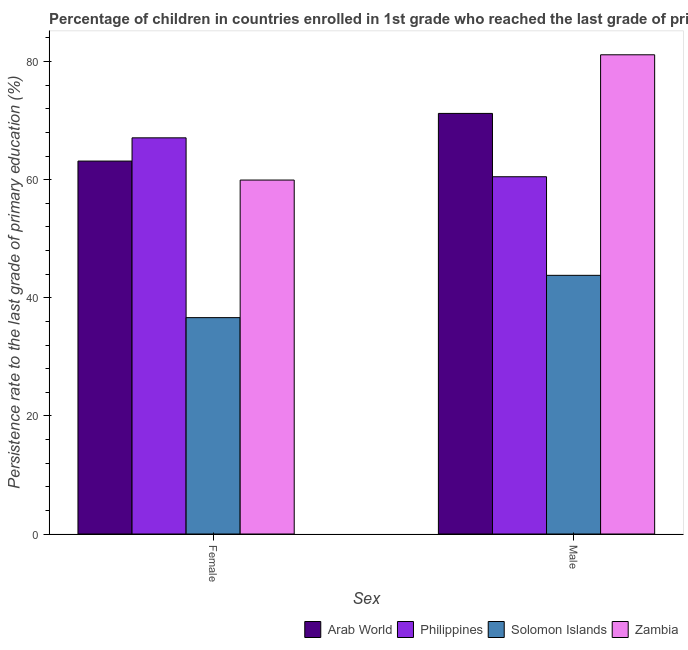How many groups of bars are there?
Offer a very short reply. 2. Are the number of bars per tick equal to the number of legend labels?
Your answer should be very brief. Yes. How many bars are there on the 1st tick from the right?
Your response must be concise. 4. What is the persistence rate of male students in Solomon Islands?
Provide a succinct answer. 43.81. Across all countries, what is the maximum persistence rate of female students?
Give a very brief answer. 67.09. Across all countries, what is the minimum persistence rate of male students?
Keep it short and to the point. 43.81. In which country was the persistence rate of male students maximum?
Keep it short and to the point. Zambia. In which country was the persistence rate of female students minimum?
Ensure brevity in your answer.  Solomon Islands. What is the total persistence rate of female students in the graph?
Offer a very short reply. 226.83. What is the difference between the persistence rate of male students in Philippines and that in Arab World?
Give a very brief answer. -10.73. What is the difference between the persistence rate of female students in Philippines and the persistence rate of male students in Arab World?
Your answer should be very brief. -4.14. What is the average persistence rate of male students per country?
Provide a short and direct response. 64.17. What is the difference between the persistence rate of male students and persistence rate of female students in Zambia?
Your answer should be compact. 21.22. What is the ratio of the persistence rate of male students in Philippines to that in Arab World?
Offer a terse response. 0.85. Is the persistence rate of male students in Zambia less than that in Solomon Islands?
Offer a terse response. No. What does the 4th bar from the left in Female represents?
Make the answer very short. Zambia. What does the 1st bar from the right in Male represents?
Give a very brief answer. Zambia. How many bars are there?
Provide a succinct answer. 8. Are all the bars in the graph horizontal?
Your answer should be very brief. No. How many countries are there in the graph?
Provide a short and direct response. 4. What is the difference between two consecutive major ticks on the Y-axis?
Offer a very short reply. 20. Where does the legend appear in the graph?
Provide a succinct answer. Bottom right. How many legend labels are there?
Offer a terse response. 4. How are the legend labels stacked?
Make the answer very short. Horizontal. What is the title of the graph?
Give a very brief answer. Percentage of children in countries enrolled in 1st grade who reached the last grade of primary education. Does "Dominica" appear as one of the legend labels in the graph?
Your answer should be compact. No. What is the label or title of the X-axis?
Your answer should be very brief. Sex. What is the label or title of the Y-axis?
Offer a terse response. Persistence rate to the last grade of primary education (%). What is the Persistence rate to the last grade of primary education (%) of Arab World in Female?
Provide a short and direct response. 63.16. What is the Persistence rate to the last grade of primary education (%) of Philippines in Female?
Your answer should be very brief. 67.09. What is the Persistence rate to the last grade of primary education (%) of Solomon Islands in Female?
Offer a terse response. 36.64. What is the Persistence rate to the last grade of primary education (%) of Zambia in Female?
Give a very brief answer. 59.94. What is the Persistence rate to the last grade of primary education (%) of Arab World in Male?
Offer a very short reply. 71.23. What is the Persistence rate to the last grade of primary education (%) in Philippines in Male?
Offer a terse response. 60.5. What is the Persistence rate to the last grade of primary education (%) of Solomon Islands in Male?
Ensure brevity in your answer.  43.81. What is the Persistence rate to the last grade of primary education (%) in Zambia in Male?
Your response must be concise. 81.16. Across all Sex, what is the maximum Persistence rate to the last grade of primary education (%) of Arab World?
Keep it short and to the point. 71.23. Across all Sex, what is the maximum Persistence rate to the last grade of primary education (%) in Philippines?
Offer a very short reply. 67.09. Across all Sex, what is the maximum Persistence rate to the last grade of primary education (%) in Solomon Islands?
Offer a very short reply. 43.81. Across all Sex, what is the maximum Persistence rate to the last grade of primary education (%) in Zambia?
Your response must be concise. 81.16. Across all Sex, what is the minimum Persistence rate to the last grade of primary education (%) of Arab World?
Your answer should be compact. 63.16. Across all Sex, what is the minimum Persistence rate to the last grade of primary education (%) of Philippines?
Keep it short and to the point. 60.5. Across all Sex, what is the minimum Persistence rate to the last grade of primary education (%) in Solomon Islands?
Make the answer very short. 36.64. Across all Sex, what is the minimum Persistence rate to the last grade of primary education (%) in Zambia?
Provide a succinct answer. 59.94. What is the total Persistence rate to the last grade of primary education (%) of Arab World in the graph?
Give a very brief answer. 134.39. What is the total Persistence rate to the last grade of primary education (%) in Philippines in the graph?
Provide a short and direct response. 127.59. What is the total Persistence rate to the last grade of primary education (%) of Solomon Islands in the graph?
Give a very brief answer. 80.45. What is the total Persistence rate to the last grade of primary education (%) of Zambia in the graph?
Offer a very short reply. 141.1. What is the difference between the Persistence rate to the last grade of primary education (%) of Arab World in Female and that in Male?
Provide a short and direct response. -8.07. What is the difference between the Persistence rate to the last grade of primary education (%) in Philippines in Female and that in Male?
Provide a succinct answer. 6.59. What is the difference between the Persistence rate to the last grade of primary education (%) of Solomon Islands in Female and that in Male?
Offer a terse response. -7.16. What is the difference between the Persistence rate to the last grade of primary education (%) in Zambia in Female and that in Male?
Provide a succinct answer. -21.22. What is the difference between the Persistence rate to the last grade of primary education (%) in Arab World in Female and the Persistence rate to the last grade of primary education (%) in Philippines in Male?
Make the answer very short. 2.65. What is the difference between the Persistence rate to the last grade of primary education (%) in Arab World in Female and the Persistence rate to the last grade of primary education (%) in Solomon Islands in Male?
Offer a terse response. 19.35. What is the difference between the Persistence rate to the last grade of primary education (%) in Arab World in Female and the Persistence rate to the last grade of primary education (%) in Zambia in Male?
Make the answer very short. -18. What is the difference between the Persistence rate to the last grade of primary education (%) of Philippines in Female and the Persistence rate to the last grade of primary education (%) of Solomon Islands in Male?
Make the answer very short. 23.29. What is the difference between the Persistence rate to the last grade of primary education (%) in Philippines in Female and the Persistence rate to the last grade of primary education (%) in Zambia in Male?
Offer a very short reply. -14.06. What is the difference between the Persistence rate to the last grade of primary education (%) in Solomon Islands in Female and the Persistence rate to the last grade of primary education (%) in Zambia in Male?
Give a very brief answer. -44.51. What is the average Persistence rate to the last grade of primary education (%) in Arab World per Sex?
Your response must be concise. 67.19. What is the average Persistence rate to the last grade of primary education (%) in Philippines per Sex?
Your answer should be compact. 63.8. What is the average Persistence rate to the last grade of primary education (%) of Solomon Islands per Sex?
Your answer should be compact. 40.22. What is the average Persistence rate to the last grade of primary education (%) of Zambia per Sex?
Give a very brief answer. 70.55. What is the difference between the Persistence rate to the last grade of primary education (%) of Arab World and Persistence rate to the last grade of primary education (%) of Philippines in Female?
Offer a very short reply. -3.93. What is the difference between the Persistence rate to the last grade of primary education (%) in Arab World and Persistence rate to the last grade of primary education (%) in Solomon Islands in Female?
Give a very brief answer. 26.52. What is the difference between the Persistence rate to the last grade of primary education (%) in Arab World and Persistence rate to the last grade of primary education (%) in Zambia in Female?
Provide a succinct answer. 3.22. What is the difference between the Persistence rate to the last grade of primary education (%) in Philippines and Persistence rate to the last grade of primary education (%) in Solomon Islands in Female?
Provide a succinct answer. 30.45. What is the difference between the Persistence rate to the last grade of primary education (%) of Philippines and Persistence rate to the last grade of primary education (%) of Zambia in Female?
Your response must be concise. 7.15. What is the difference between the Persistence rate to the last grade of primary education (%) of Solomon Islands and Persistence rate to the last grade of primary education (%) of Zambia in Female?
Keep it short and to the point. -23.3. What is the difference between the Persistence rate to the last grade of primary education (%) in Arab World and Persistence rate to the last grade of primary education (%) in Philippines in Male?
Provide a short and direct response. 10.73. What is the difference between the Persistence rate to the last grade of primary education (%) in Arab World and Persistence rate to the last grade of primary education (%) in Solomon Islands in Male?
Provide a succinct answer. 27.42. What is the difference between the Persistence rate to the last grade of primary education (%) of Arab World and Persistence rate to the last grade of primary education (%) of Zambia in Male?
Ensure brevity in your answer.  -9.93. What is the difference between the Persistence rate to the last grade of primary education (%) of Philippines and Persistence rate to the last grade of primary education (%) of Solomon Islands in Male?
Provide a short and direct response. 16.7. What is the difference between the Persistence rate to the last grade of primary education (%) in Philippines and Persistence rate to the last grade of primary education (%) in Zambia in Male?
Give a very brief answer. -20.65. What is the difference between the Persistence rate to the last grade of primary education (%) of Solomon Islands and Persistence rate to the last grade of primary education (%) of Zambia in Male?
Offer a terse response. -37.35. What is the ratio of the Persistence rate to the last grade of primary education (%) in Arab World in Female to that in Male?
Keep it short and to the point. 0.89. What is the ratio of the Persistence rate to the last grade of primary education (%) in Philippines in Female to that in Male?
Your answer should be compact. 1.11. What is the ratio of the Persistence rate to the last grade of primary education (%) in Solomon Islands in Female to that in Male?
Provide a short and direct response. 0.84. What is the ratio of the Persistence rate to the last grade of primary education (%) of Zambia in Female to that in Male?
Your answer should be compact. 0.74. What is the difference between the highest and the second highest Persistence rate to the last grade of primary education (%) in Arab World?
Ensure brevity in your answer.  8.07. What is the difference between the highest and the second highest Persistence rate to the last grade of primary education (%) in Philippines?
Provide a succinct answer. 6.59. What is the difference between the highest and the second highest Persistence rate to the last grade of primary education (%) in Solomon Islands?
Your answer should be very brief. 7.16. What is the difference between the highest and the second highest Persistence rate to the last grade of primary education (%) of Zambia?
Your response must be concise. 21.22. What is the difference between the highest and the lowest Persistence rate to the last grade of primary education (%) of Arab World?
Offer a very short reply. 8.07. What is the difference between the highest and the lowest Persistence rate to the last grade of primary education (%) of Philippines?
Your answer should be compact. 6.59. What is the difference between the highest and the lowest Persistence rate to the last grade of primary education (%) in Solomon Islands?
Provide a short and direct response. 7.16. What is the difference between the highest and the lowest Persistence rate to the last grade of primary education (%) in Zambia?
Provide a succinct answer. 21.22. 